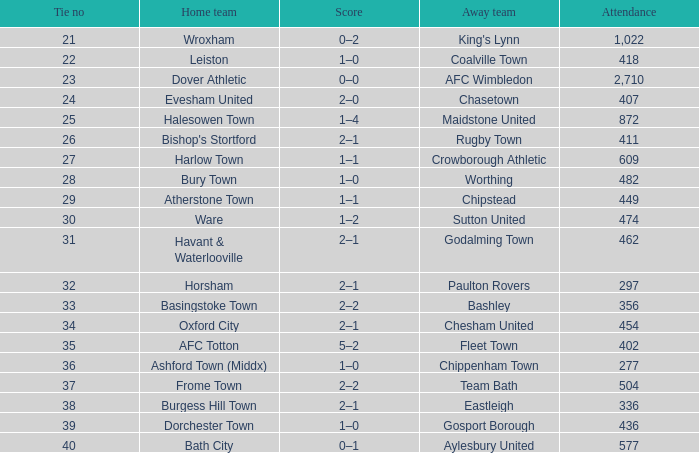Give me the full table as a dictionary. {'header': ['Tie no', 'Home team', 'Score', 'Away team', 'Attendance'], 'rows': [['21', 'Wroxham', '0–2', "King's Lynn", '1,022'], ['22', 'Leiston', '1–0', 'Coalville Town', '418'], ['23', 'Dover Athletic', '0–0', 'AFC Wimbledon', '2,710'], ['24', 'Evesham United', '2–0', 'Chasetown', '407'], ['25', 'Halesowen Town', '1–4', 'Maidstone United', '872'], ['26', "Bishop's Stortford", '2–1', 'Rugby Town', '411'], ['27', 'Harlow Town', '1–1', 'Crowborough Athletic', '609'], ['28', 'Bury Town', '1–0', 'Worthing', '482'], ['29', 'Atherstone Town', '1–1', 'Chipstead', '449'], ['30', 'Ware', '1–2', 'Sutton United', '474'], ['31', 'Havant & Waterlooville', '2–1', 'Godalming Town', '462'], ['32', 'Horsham', '2–1', 'Paulton Rovers', '297'], ['33', 'Basingstoke Town', '2–2', 'Bashley', '356'], ['34', 'Oxford City', '2–1', 'Chesham United', '454'], ['35', 'AFC Totton', '5–2', 'Fleet Town', '402'], ['36', 'Ashford Town (Middx)', '1–0', 'Chippenham Town', '277'], ['37', 'Frome Town', '2–2', 'Team Bath', '504'], ['38', 'Burgess Hill Town', '2–1', 'Eastleigh', '336'], ['39', 'Dorchester Town', '1–0', 'Gosport Borough', '436'], ['40', 'Bath City', '0–1', 'Aylesbury United', '577']]} What is the away team of the match with a 356 attendance? Bashley. 